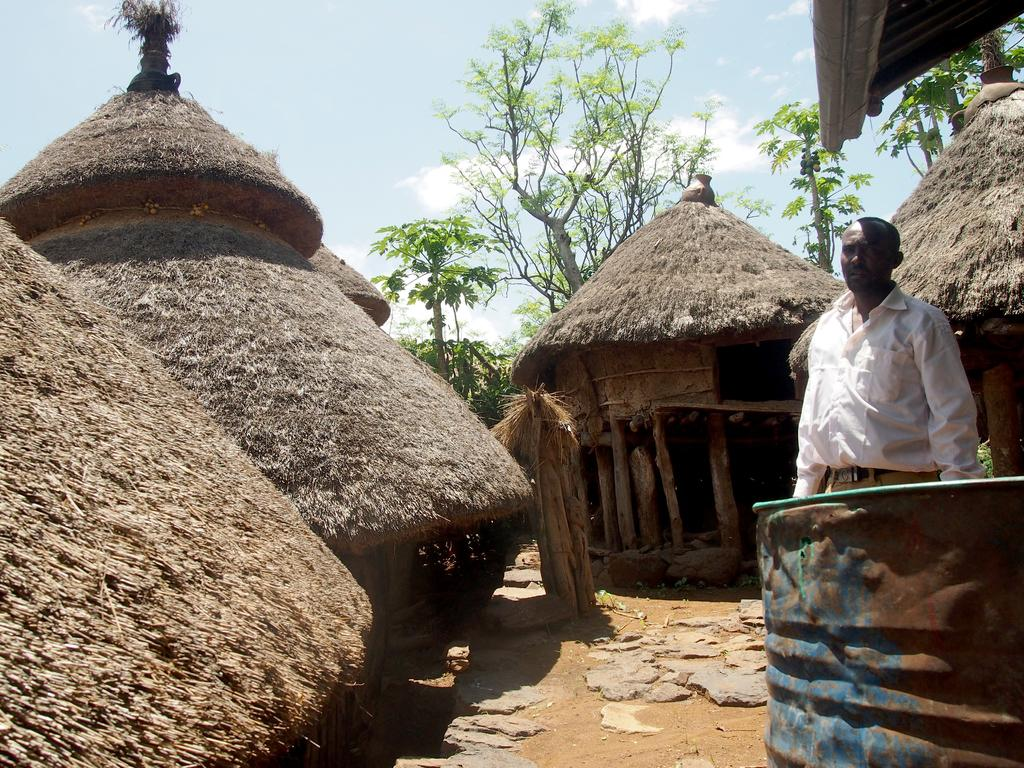What type of structures are visible in the image? There are small huts in the image. Can you describe the person in the image? There is a man standing on the right side of the image. What can be seen in the background of the image? There are trees in the background of the image. What type of cork is the man holding in the image? There is no cork present in the image; the man is not holding anything. How does the stocking fit into the scene in the image? There is no stocking present in the image, so it cannot fit into the scene. 